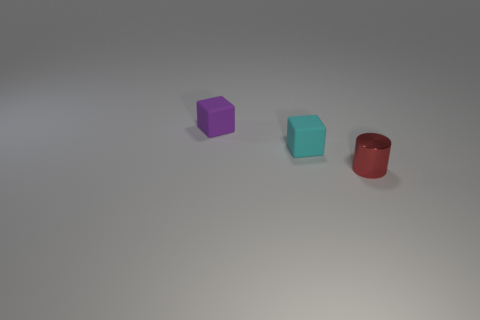What number of other objects are there of the same material as the tiny red object?
Your response must be concise. 0. How many red objects are either tiny objects or shiny things?
Keep it short and to the point. 1. There is a small matte object right of the purple matte thing; is it the same shape as the small thing that is to the left of the cyan object?
Your answer should be very brief. Yes. Does the small cylinder have the same color as the small cube that is to the left of the small cyan thing?
Keep it short and to the point. No. There is a tiny rubber cube in front of the purple matte object; is it the same color as the small metal thing?
Ensure brevity in your answer.  No. How many things are either tiny brown matte objects or small objects that are on the left side of the small red metal thing?
Make the answer very short. 2. There is a small thing that is to the right of the purple rubber cube and on the left side of the small red cylinder; what is its material?
Provide a succinct answer. Rubber. What is the tiny cube in front of the small purple rubber cube made of?
Give a very brief answer. Rubber. There is a tiny cube that is made of the same material as the tiny purple thing; what is its color?
Your response must be concise. Cyan. There is a tiny cyan object; is it the same shape as the matte object that is on the left side of the cyan thing?
Offer a very short reply. Yes. 